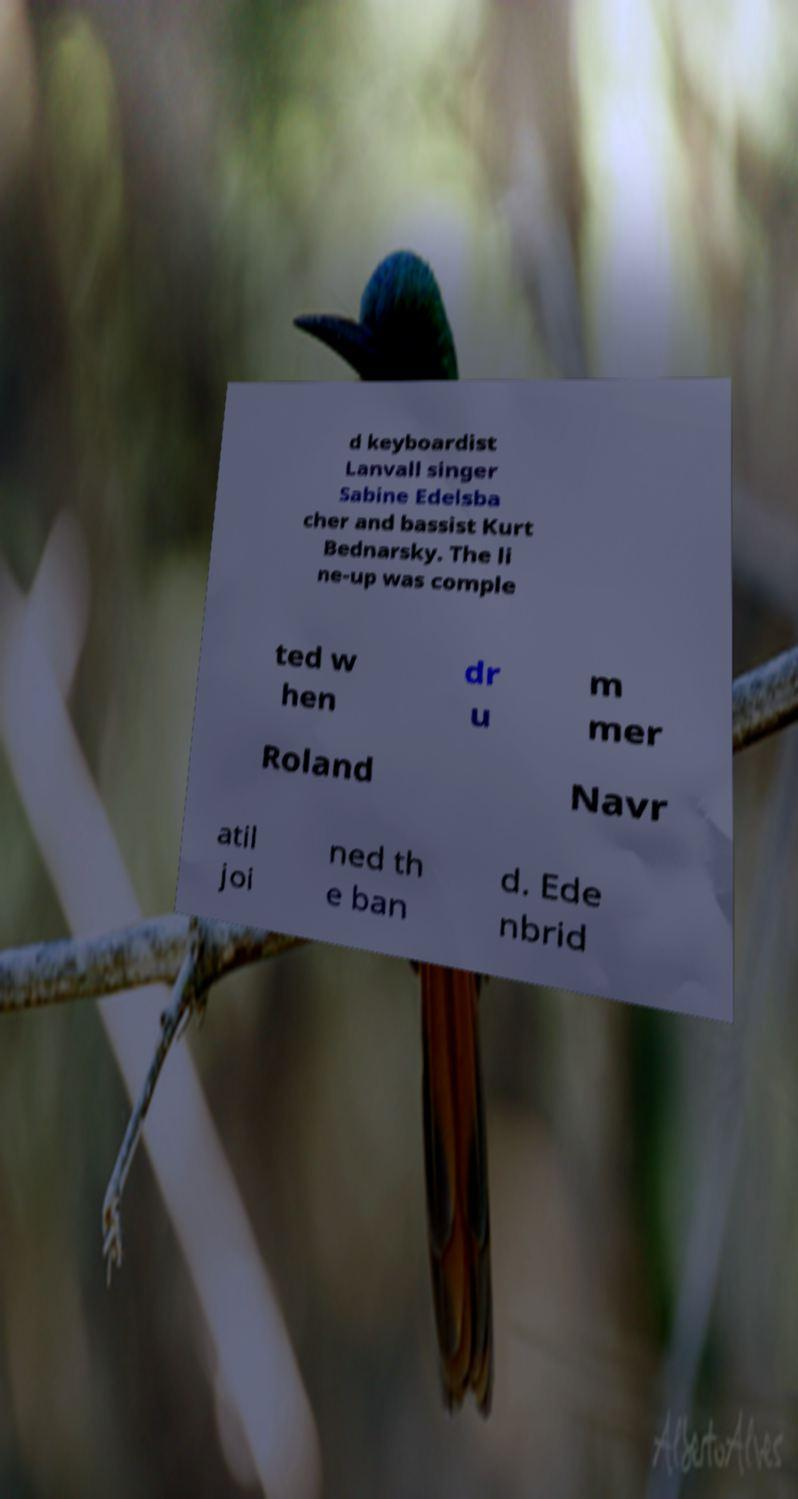I need the written content from this picture converted into text. Can you do that? d keyboardist Lanvall singer Sabine Edelsba cher and bassist Kurt Bednarsky. The li ne-up was comple ted w hen dr u m mer Roland Navr atil joi ned th e ban d. Ede nbrid 